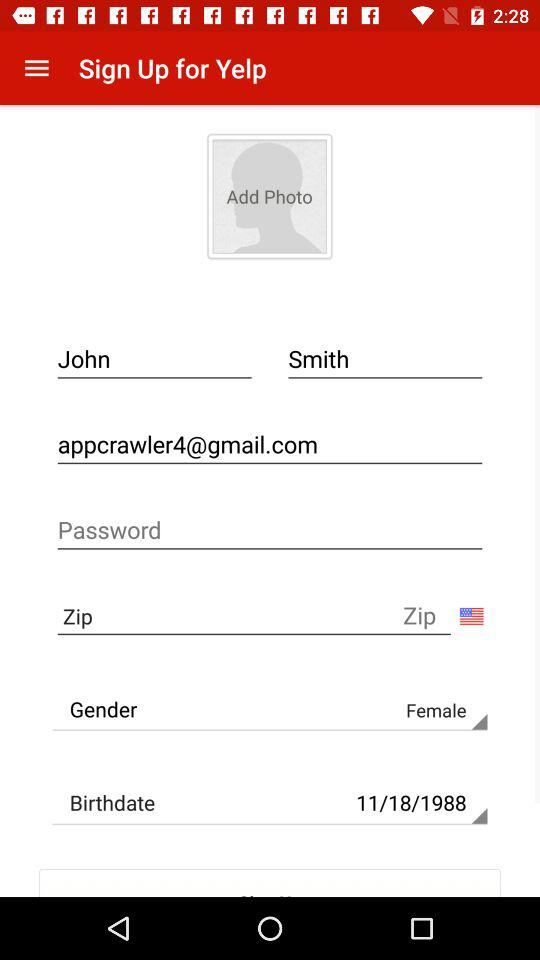What's the Google mail address? The Google mail address is "appcrawler4@gmail.com". 